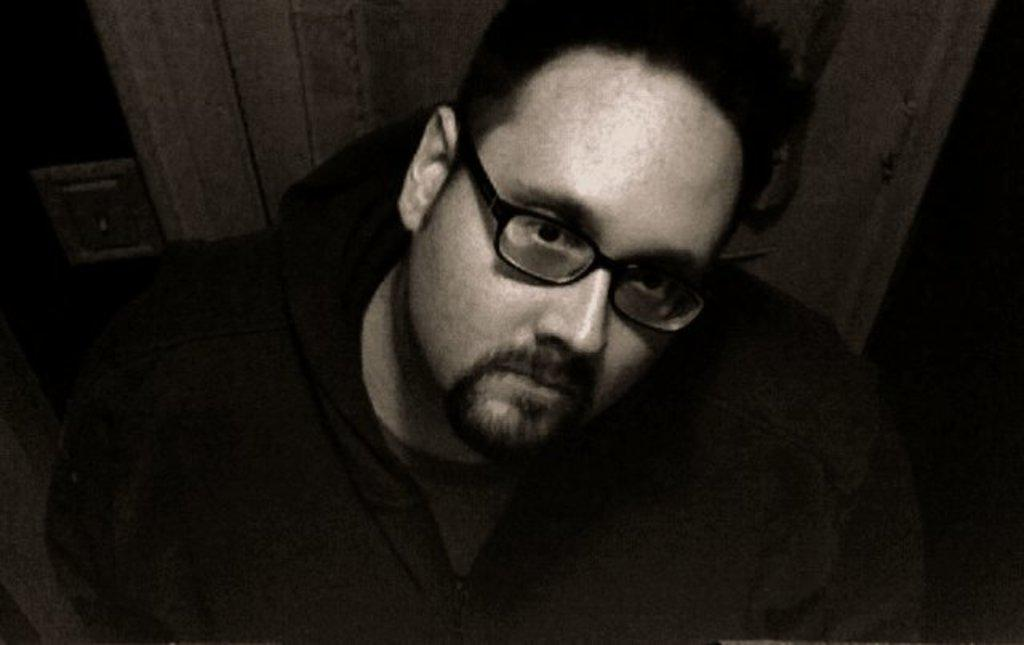What is the color scheme of the image? The image is black and white. Can you describe the person in the image? The person in the image is wearing glasses. What can be said about the background of the image? The background of the image is not clear. What type of stamp is the person holding in the image? There is no stamp present in the image; the person is wearing glasses. Where is the playground located in the image? There is no playground present in the image; it features a person wearing glasses in a black and white setting with an unclear background. 